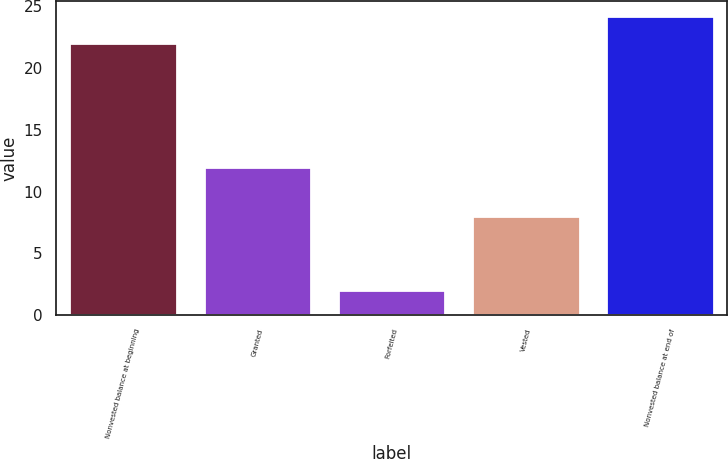Convert chart to OTSL. <chart><loc_0><loc_0><loc_500><loc_500><bar_chart><fcel>Nonvested balance at beginning<fcel>Granted<fcel>Forfeited<fcel>Vested<fcel>Nonvested balance at end of<nl><fcel>22<fcel>12<fcel>2<fcel>8<fcel>24.2<nl></chart> 